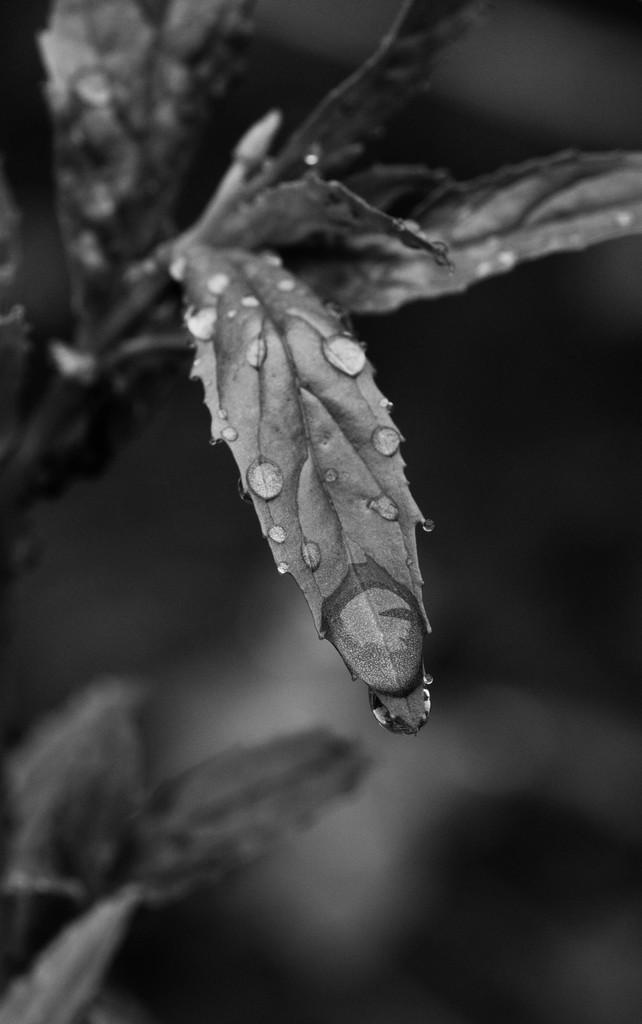What type of vegetation can be seen in the image? There are leaves in the image. What is the condition of the leaves? There are water droplets on the leaves. What is the color scheme of the image? The image is black and white. What is the focus of the image? The leaves are the main subject, while the background is completely blurred. Can you see any trails of blood on the leaves in the image? There is no blood present in the image; it only features leaves with water droplets. What type of exchange is happening between the leaves in the image? There is no exchange happening between the leaves in the image; they are simply depicted with water droplets. 